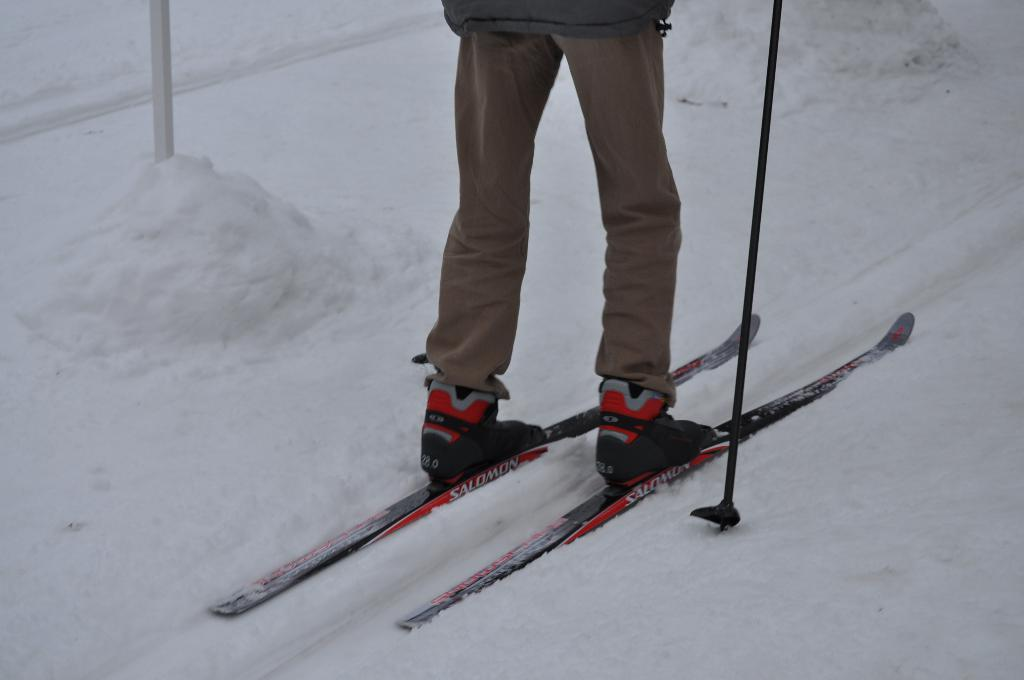What is the main subject of the image? There is a person in the image. What is the person doing in the image? The person is standing on snow skates. What type of terrain is visible in the image? The ground is filled with snow. What type of cabbage can be seen growing in the snow in the image? There is: There is no cabbage present in the image; the ground is filled with snow, and the person is standing on snow skates. 